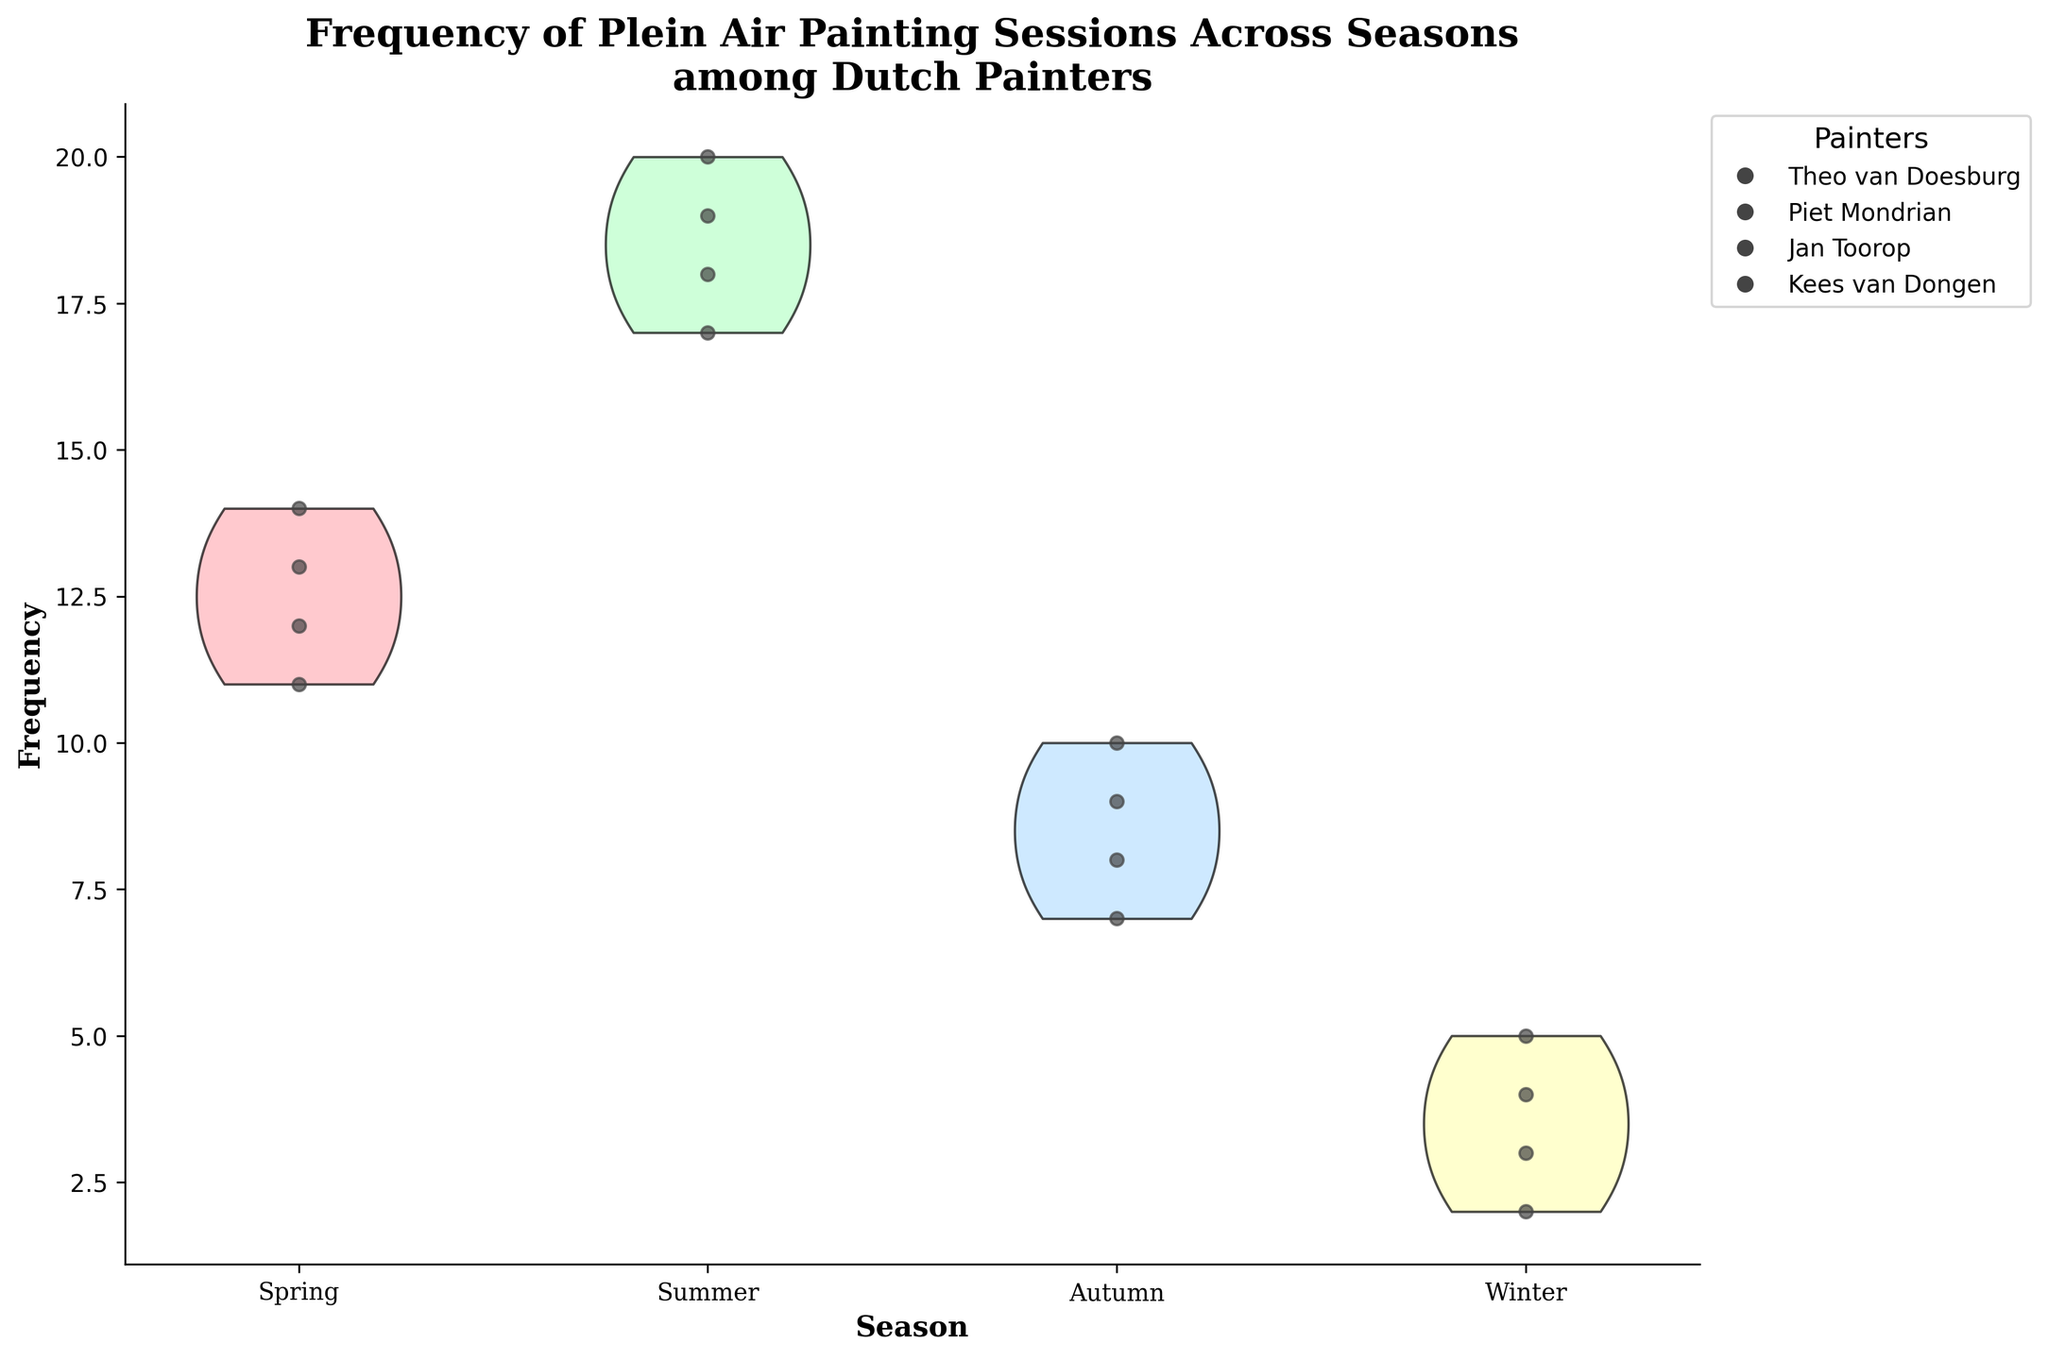What season has the highest median frequency of plein air painting sessions among the painters? To find the season with the highest median frequency, we look at the width of each violin plot's center. Summer has the widest center, indicating the highest median frequency.
Answer: Summer How does the frequency of Jan Toorop’s painting sessions in Autumn compare to Winter? By referring to the scatter plot, we can see that Jan Toorop's sessions in Autumn (7) are more frequent than in Winter (3).
Answer: Autumn > Winter Which painter has the lowest frequency of painting sessions during Winter? Looking at the scatter plots within the Winter section, we observe that Theo van Doesburg has the lowest frequency (2 sessions).
Answer: Theo van Doesburg What's the average frequency of painting sessions for all painters during Spring? Add up the frequencies for Spring for all painters: 12 (Theo van Doesburg) + 14 (Piet Mondrian) + 11 (Jan Toorop) + 13 (Kees van Dongen) = 50, and then divide by the number of painters (4). 50 / 4 = 12.5
Answer: 12.5 Which season shows the greatest range in the frequency of painting sessions among the painters? The range is the difference between the highest and lowest frequencies for each season. By comparing the ranges: Spring (14 - 11 = 3), Summer (20 - 17 = 3), Autumn (10 - 7 = 3), and Winter (5 - 2 = 3). All seasons have the same range.
Answer: All seasons How many painting sessions did Piet Mondrian have in Summer? By observing the scatter plot in the Summer section, we can see Piet Mondrian had 20 painting sessions.
Answer: 20 Which season shows the most uniform distribution of painting frequencies across different painters? By assessing the spread and shape of the violin plots, Spring and Winter appear more uniform due to their narrower shape compared to Summer and Autumn.
Answer: Spring and Winter What is the overall trend in the frequency of plein air painting sessions from Spring to Winter? Observing the violin plots' heights, there's an overall decreasing trend from Spring (high) to Winter (low).
Answer: Decreasing trend Is Kees van Dongen's frequency of painting sessions in Summer higher than his frequency in Spring? Comparing the scatter plots, Kees van Dongen had 19 sessions in Summer, which is higher than his 13 sessions in Spring.
Answer: Yes 